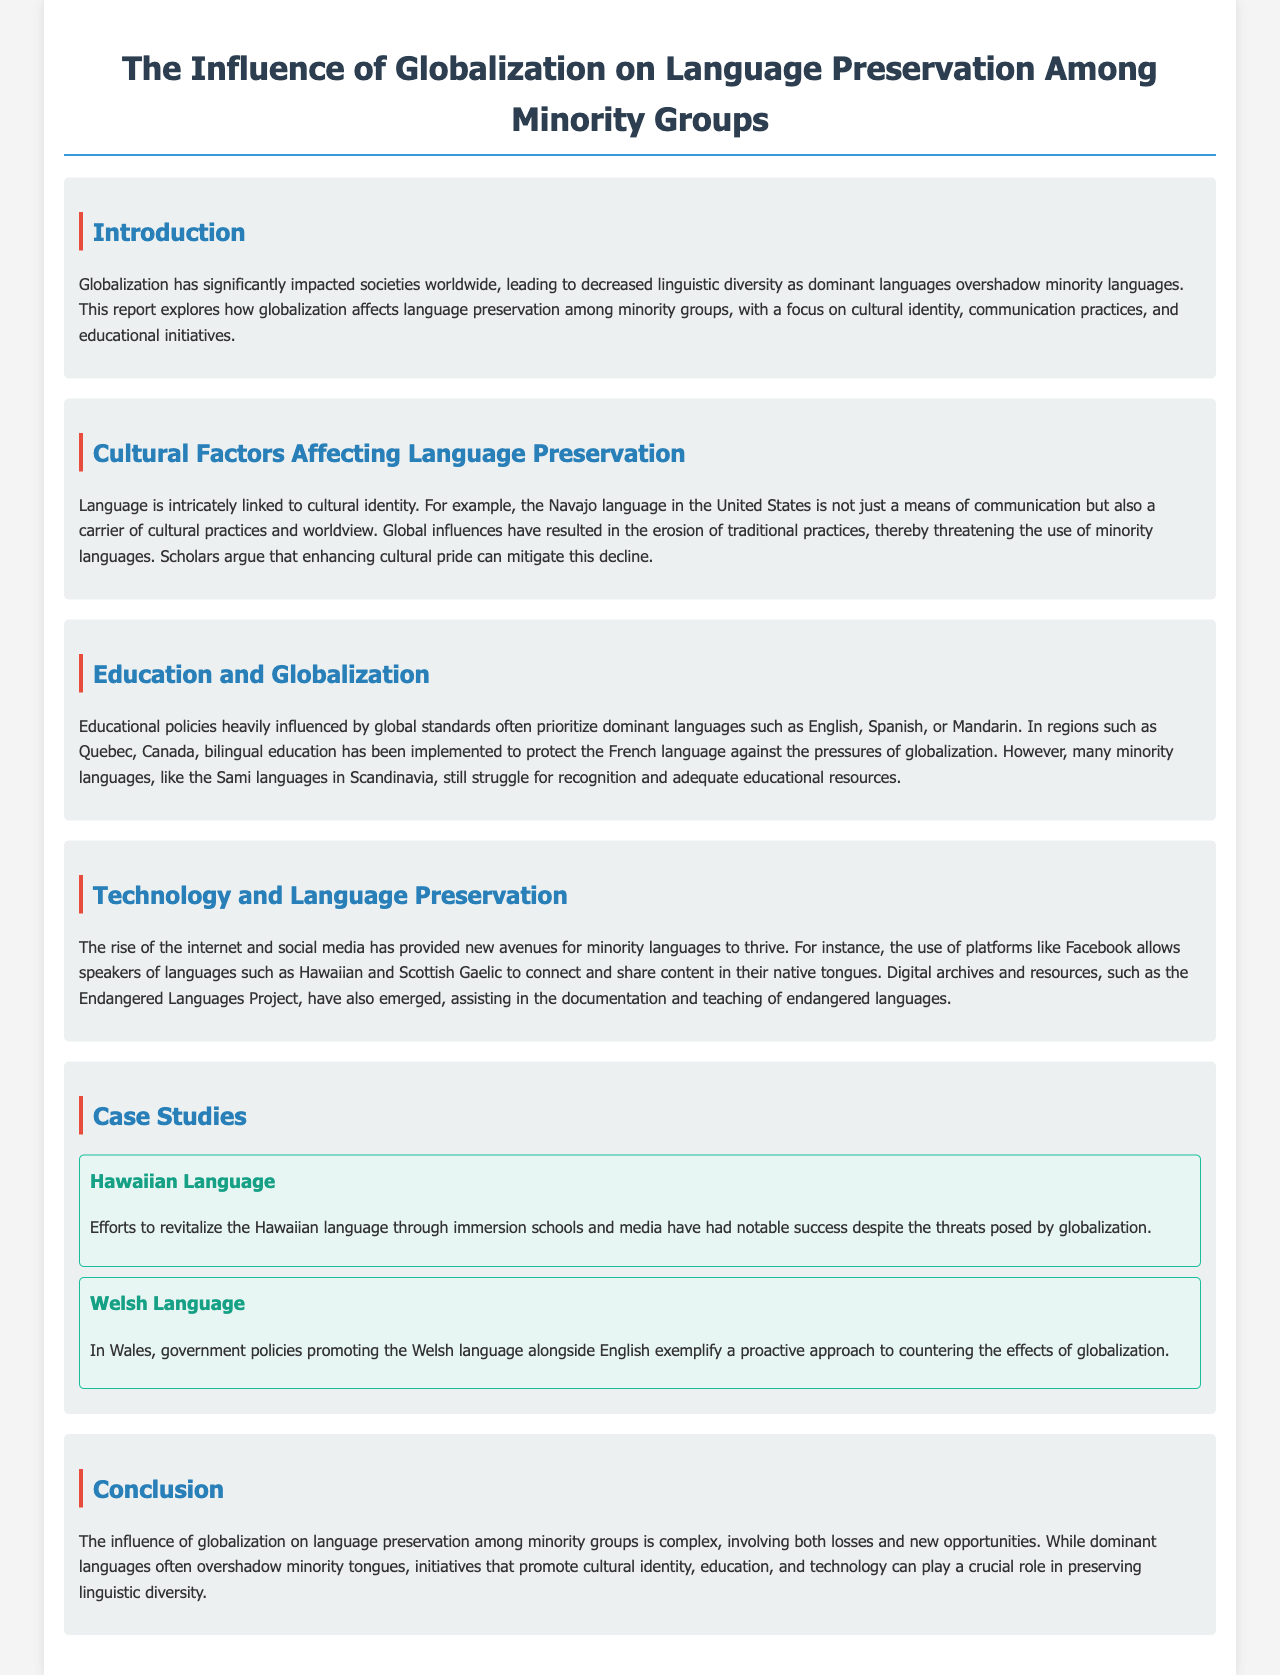What is the main effect of globalization on linguistic diversity? The document states that globalization has led to decreased linguistic diversity as dominant languages overshadow minority languages.
Answer: decreased linguistic diversity Which language is highlighted as being a carrier of cultural practices in the United States? The document mentions the Navajo language as linked to cultural identity and practices.
Answer: Navajo What initiative has been implemented in Quebec to protect the French language? The document states that bilingual education has been implemented in Quebec to protect the French language.
Answer: bilingual education Which two languages are mentioned as being connected through social media? The document highlights Hawaiian and Scottish Gaelic as languages thriving on platforms like Facebook.
Answer: Hawaiian and Scottish Gaelic What resource has emerged to assist in documenting endangered languages? The document refers to the Endangered Languages Project as a resource for documenting endangered languages.
Answer: Endangered Languages Project Which two case studies are presented in the report? The document includes case studies on the Hawaiian Language and the Welsh Language.
Answer: Hawaiian Language and Welsh Language What has been a noted success for the Hawaiian language? The report discusses the success of efforts to revitalize the Hawaiian language through immersion schools and media.
Answer: immersion schools and media What is a proactive approach mentioned in the document for countering globalization effects? The document points out that government policies promoting the Welsh language alongside English exemplify a proactive approach.
Answer: government policies promoting 